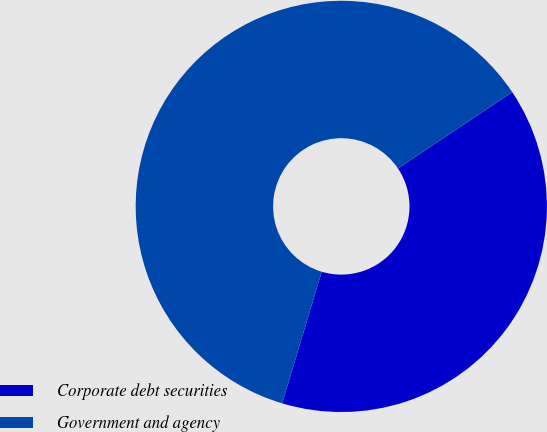Convert chart to OTSL. <chart><loc_0><loc_0><loc_500><loc_500><pie_chart><fcel>Corporate debt securities<fcel>Government and agency<nl><fcel>39.02%<fcel>60.98%<nl></chart> 